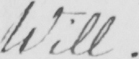Please transcribe the handwritten text in this image. Will. 